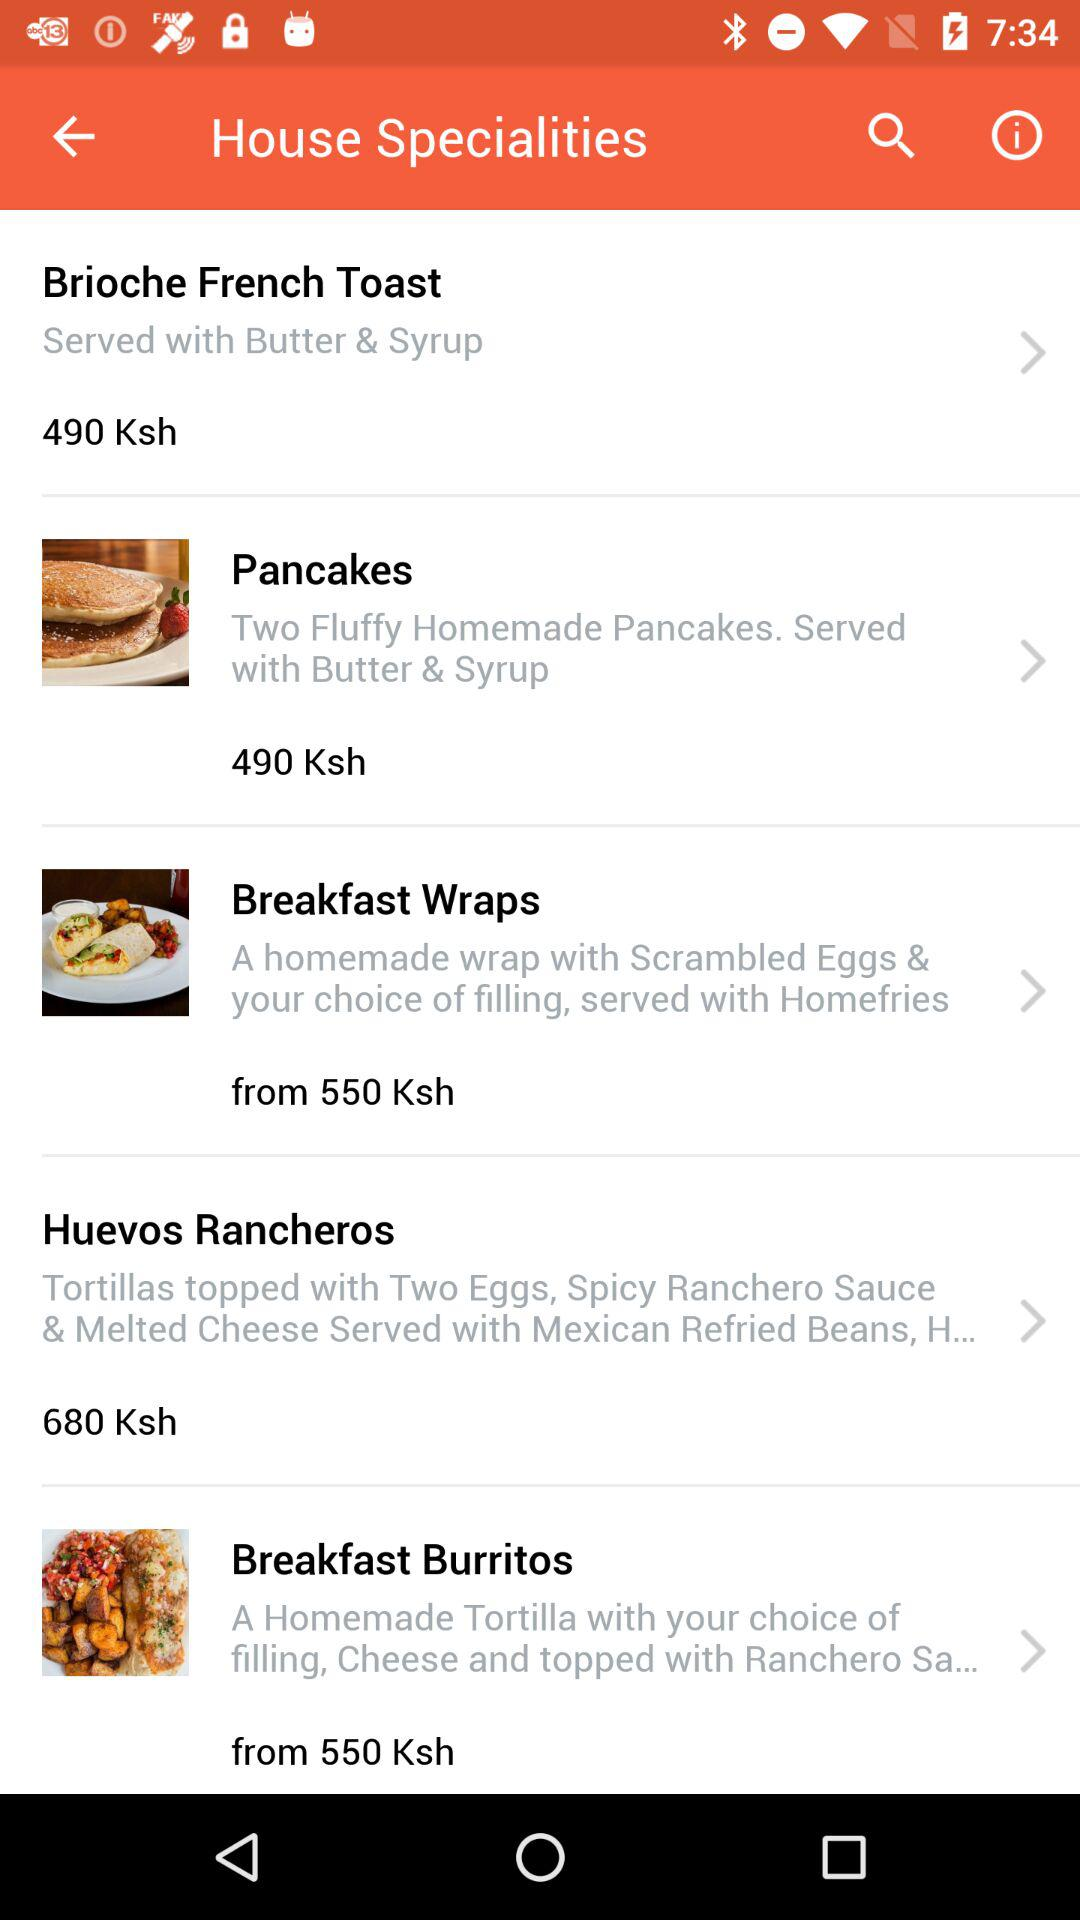What is the name of the dish that costs 680 Ksh? The name of the dish that costs 680 Ksh is "Huevos Rancheros". 